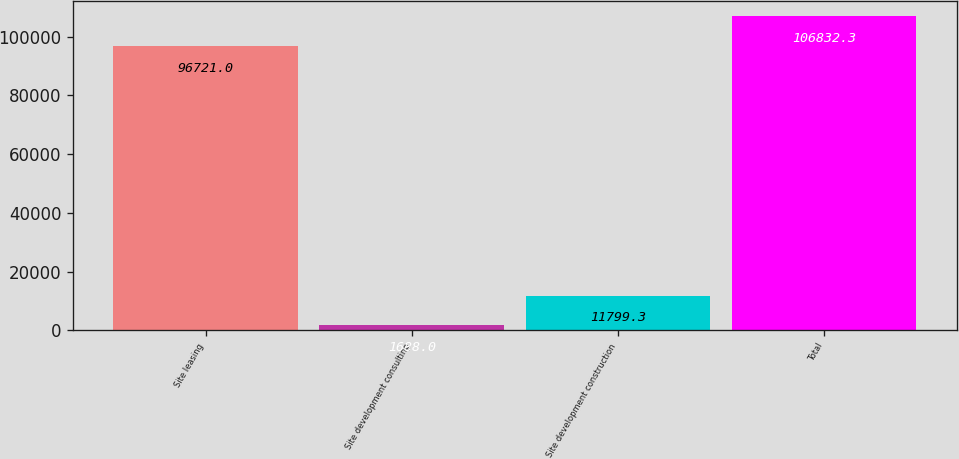<chart> <loc_0><loc_0><loc_500><loc_500><bar_chart><fcel>Site leasing<fcel>Site development consulting<fcel>Site development construction<fcel>Total<nl><fcel>96721<fcel>1688<fcel>11799.3<fcel>106832<nl></chart> 